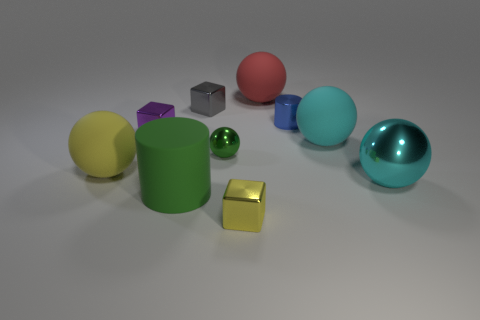Subtract all big cyan balls. How many balls are left? 3 Subtract all cyan cubes. How many cyan balls are left? 2 Subtract all cyan balls. How many balls are left? 3 Subtract 1 cubes. How many cubes are left? 2 Subtract all cyan blocks. Subtract all gray balls. How many blocks are left? 3 Subtract all cylinders. How many objects are left? 8 Subtract all small red metallic cylinders. Subtract all cyan spheres. How many objects are left? 8 Add 1 metal balls. How many metal balls are left? 3 Add 6 big balls. How many big balls exist? 10 Subtract 0 blue cubes. How many objects are left? 10 